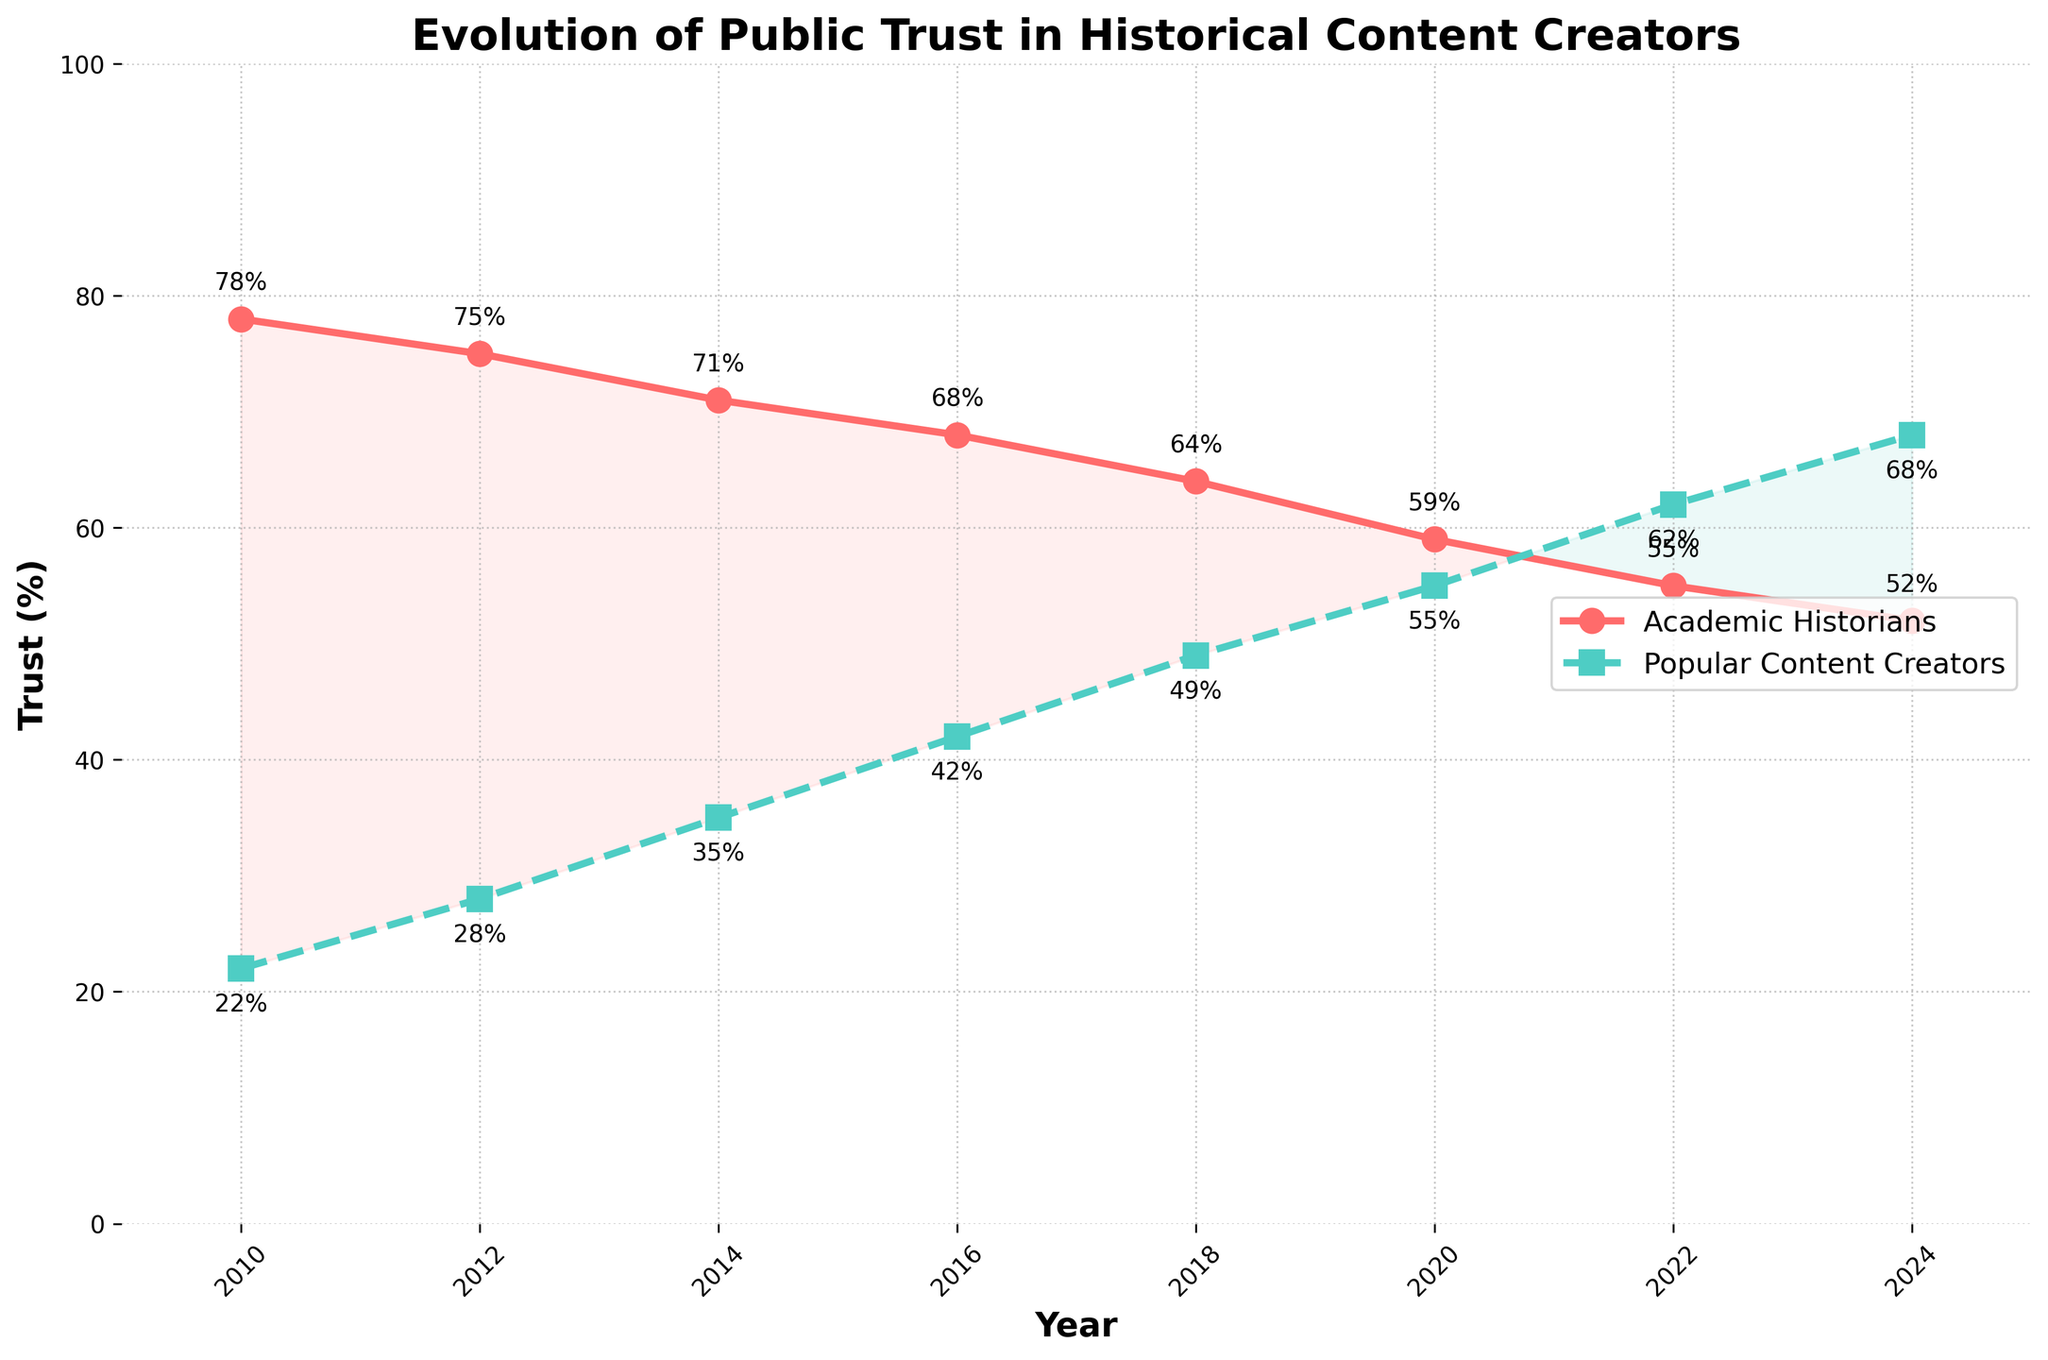How has the trust in Academic Historians changed over time? To find how the trust in Academic Historians has changed, we can look at their trust percentages across the years 2010 to 2024. In 2010, the trust was at 78%, and it generally declined each subsequent year, ending at 52% in 2024.
Answer: It has declined Between which years did Popular History Content Creators see the largest increase in trust? To determine the largest increase, we compare the changes in trust percentages between each set of consecutive years. The largest increase is between 2018 (49%) and 2020 (55%), which is a 6% increase.
Answer: Between 2018 and 2020 In what year did trust in Popular History Content Creators surpass trust in Academic Historians? By comparing the trends, we see that Popular History Content Creators' trust surpassed Academic Historians' trust for the first time in 2022, where the trust levels were 62% and 55%, respectively.
Answer: 2022 What is the average trust percentage for Academic Historians from 2010 to 2024? To calculate the average, add all the trust percentages for Academic Historians from 2010 to 2024 (78 + 75 + 71 + 68 + 64 + 59 + 55 + 52) and divide by the number of years (8). So, (78 + 75 + 71 + 68 + 64 + 59 + 55 + 52) / 8 = 65.25.
Answer: 65.25% How many times have the trust percentages for Popular History Content Creators increased compared to the previous year? To determine the number of increases, we compare each consecutive year for Popular History Content Creators: 2010 to 2012 (+6), 2012 to 2014 (+7), 2014 to 2016 (+7), 2016 to 2018 (+7), 2018 to 2020 (+6), 2020 to 2022 (+7), and 2022 to 2024 (+6). Each year shows an increase, so there are 7 increases.
Answer: 7 times In 2016, how much more trust did Academic Historians have compared to Popular History Content Creators? In 2016, the trust in Academic Historians was 68%, and in Popular History Content Creators, it was 42%. The difference is 68% - 42% = 26%.
Answer: 26% What trend is observed in the trust percentages of both groups from 2010 to 2024? Observing the trend from 2010 to 2024, the trust in Academic Historians consistently decreases, while the trust in Popular History Content Creators consistently increases.
Answer: Decreasing for Academic Historians, increasing for Popular History Content Creators What was the trust value for Popular History Content Creators in 2020, and how much did it change by 2024? The trust for Popular History Content Creators in 2020 was 55%, and in 2024, it was 68%. The change is 68% - 55% = 13%.
Answer: 13% What is the sum of trust percentages for Popular History Content Creators in the years 2018 and 2020? To find the sum, add the trust percentages of 49% in 2018 and 55% in 2020. So, the sum is 49 + 55 = 104.
Answer: 104% In which year was the gap between Academic Historians and Popular History Content Creators' trust the smallest? We need to compare the differences for each year. By examining the data, the smallest gap is in 2022, where the difference is 62% (Popular) - 55% (Academic) = 7%.
Answer: 2022 